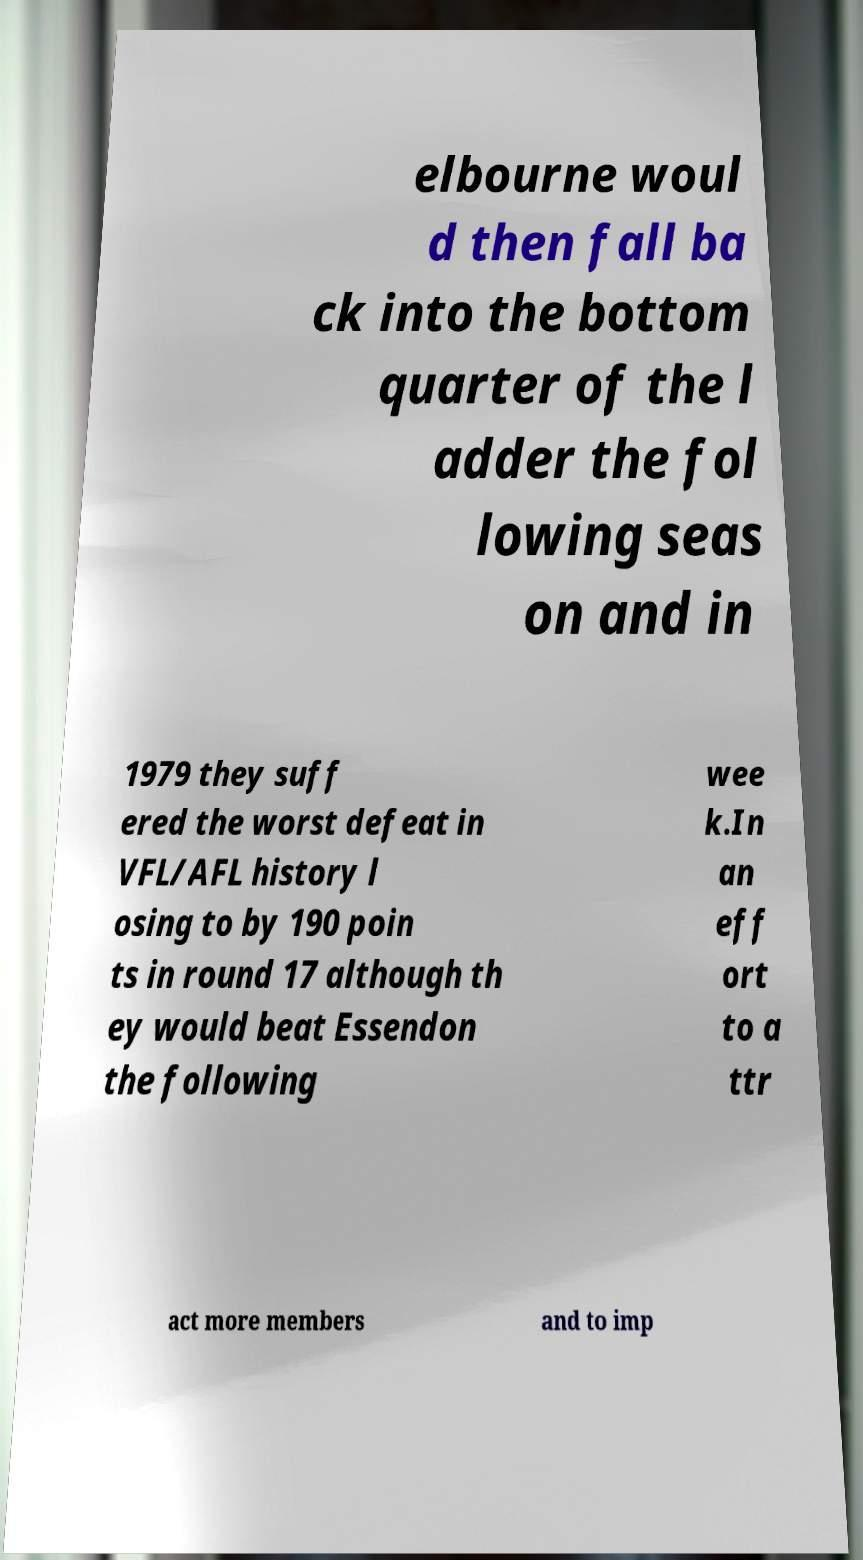There's text embedded in this image that I need extracted. Can you transcribe it verbatim? elbourne woul d then fall ba ck into the bottom quarter of the l adder the fol lowing seas on and in 1979 they suff ered the worst defeat in VFL/AFL history l osing to by 190 poin ts in round 17 although th ey would beat Essendon the following wee k.In an eff ort to a ttr act more members and to imp 